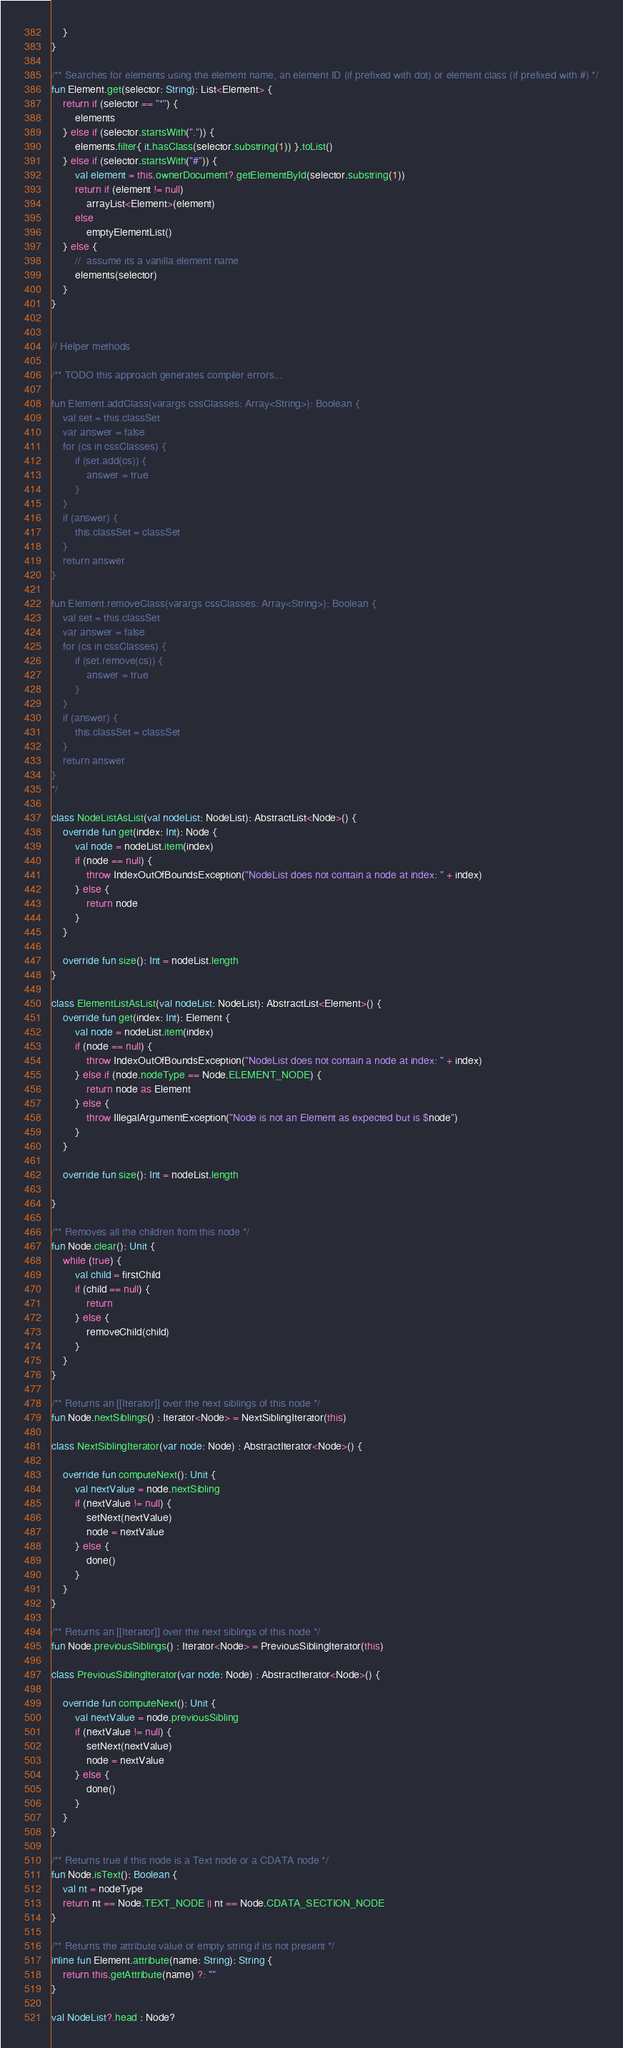Convert code to text. <code><loc_0><loc_0><loc_500><loc_500><_Kotlin_>    }
}

/** Searches for elements using the element name, an element ID (if prefixed with dot) or element class (if prefixed with #) */
fun Element.get(selector: String): List<Element> {
    return if (selector == "*") {
        elements
    } else if (selector.startsWith(".")) {
        elements.filter{ it.hasClass(selector.substring(1)) }.toList()
    } else if (selector.startsWith("#")) {
        val element = this.ownerDocument?.getElementById(selector.substring(1))
        return if (element != null)
            arrayList<Element>(element)
        else
            emptyElementList()
    } else {
        //  assume its a vanilla element name
        elements(selector)
    }
}


// Helper methods

/** TODO this approach generates compiler errors...

fun Element.addClass(varargs cssClasses: Array<String>): Boolean {
    val set = this.classSet
    var answer = false
    for (cs in cssClasses) {
        if (set.add(cs)) {
            answer = true
        }
    }
    if (answer) {
        this.classSet = classSet
    }
    return answer
}

fun Element.removeClass(varargs cssClasses: Array<String>): Boolean {
    val set = this.classSet
    var answer = false
    for (cs in cssClasses) {
        if (set.remove(cs)) {
            answer = true
        }
    }
    if (answer) {
        this.classSet = classSet
    }
    return answer
}
*/

class NodeListAsList(val nodeList: NodeList): AbstractList<Node>() {
    override fun get(index: Int): Node {
        val node = nodeList.item(index)
        if (node == null) {
            throw IndexOutOfBoundsException("NodeList does not contain a node at index: " + index)
        } else {
            return node
        }
    }

    override fun size(): Int = nodeList.length
}

class ElementListAsList(val nodeList: NodeList): AbstractList<Element>() {
    override fun get(index: Int): Element {
        val node = nodeList.item(index)
        if (node == null) {
            throw IndexOutOfBoundsException("NodeList does not contain a node at index: " + index)
        } else if (node.nodeType == Node.ELEMENT_NODE) {
            return node as Element
        } else {
            throw IllegalArgumentException("Node is not an Element as expected but is $node")
        }
    }

    override fun size(): Int = nodeList.length

}

/** Removes all the children from this node */
fun Node.clear(): Unit {
    while (true) {
        val child = firstChild
        if (child == null) {
            return
        } else {
            removeChild(child)
        }
    }
}

/** Returns an [[Iterator]] over the next siblings of this node */
fun Node.nextSiblings() : Iterator<Node> = NextSiblingIterator(this)

class NextSiblingIterator(var node: Node) : AbstractIterator<Node>() {

    override fun computeNext(): Unit {
        val nextValue = node.nextSibling
        if (nextValue != null) {
            setNext(nextValue)
            node = nextValue
        } else {
            done()
        }
    }
}

/** Returns an [[Iterator]] over the next siblings of this node */
fun Node.previousSiblings() : Iterator<Node> = PreviousSiblingIterator(this)

class PreviousSiblingIterator(var node: Node) : AbstractIterator<Node>() {

    override fun computeNext(): Unit {
        val nextValue = node.previousSibling
        if (nextValue != null) {
            setNext(nextValue)
            node = nextValue
        } else {
            done()
        }
    }
}

/** Returns true if this node is a Text node or a CDATA node */
fun Node.isText(): Boolean {
    val nt = nodeType
    return nt == Node.TEXT_NODE || nt == Node.CDATA_SECTION_NODE
}

/** Returns the attribute value or empty string if its not present */
inline fun Element.attribute(name: String): String {
    return this.getAttribute(name) ?: ""
}

val NodeList?.head : Node?</code> 